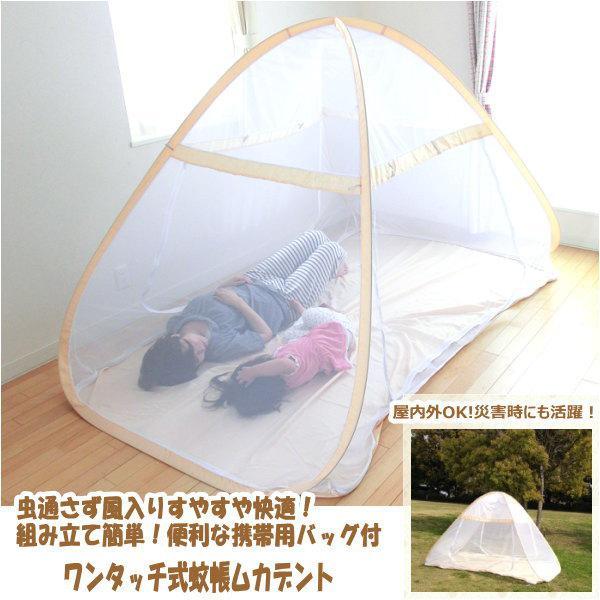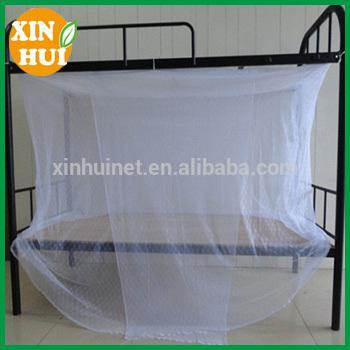The first image is the image on the left, the second image is the image on the right. Given the left and right images, does the statement "There are two canopies with at least one that is purple." hold true? Answer yes or no. No. The first image is the image on the left, the second image is the image on the right. Examine the images to the left and right. Is the description "One of the beds is a bunk bed." accurate? Answer yes or no. Yes. 